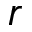<formula> <loc_0><loc_0><loc_500><loc_500>r</formula> 